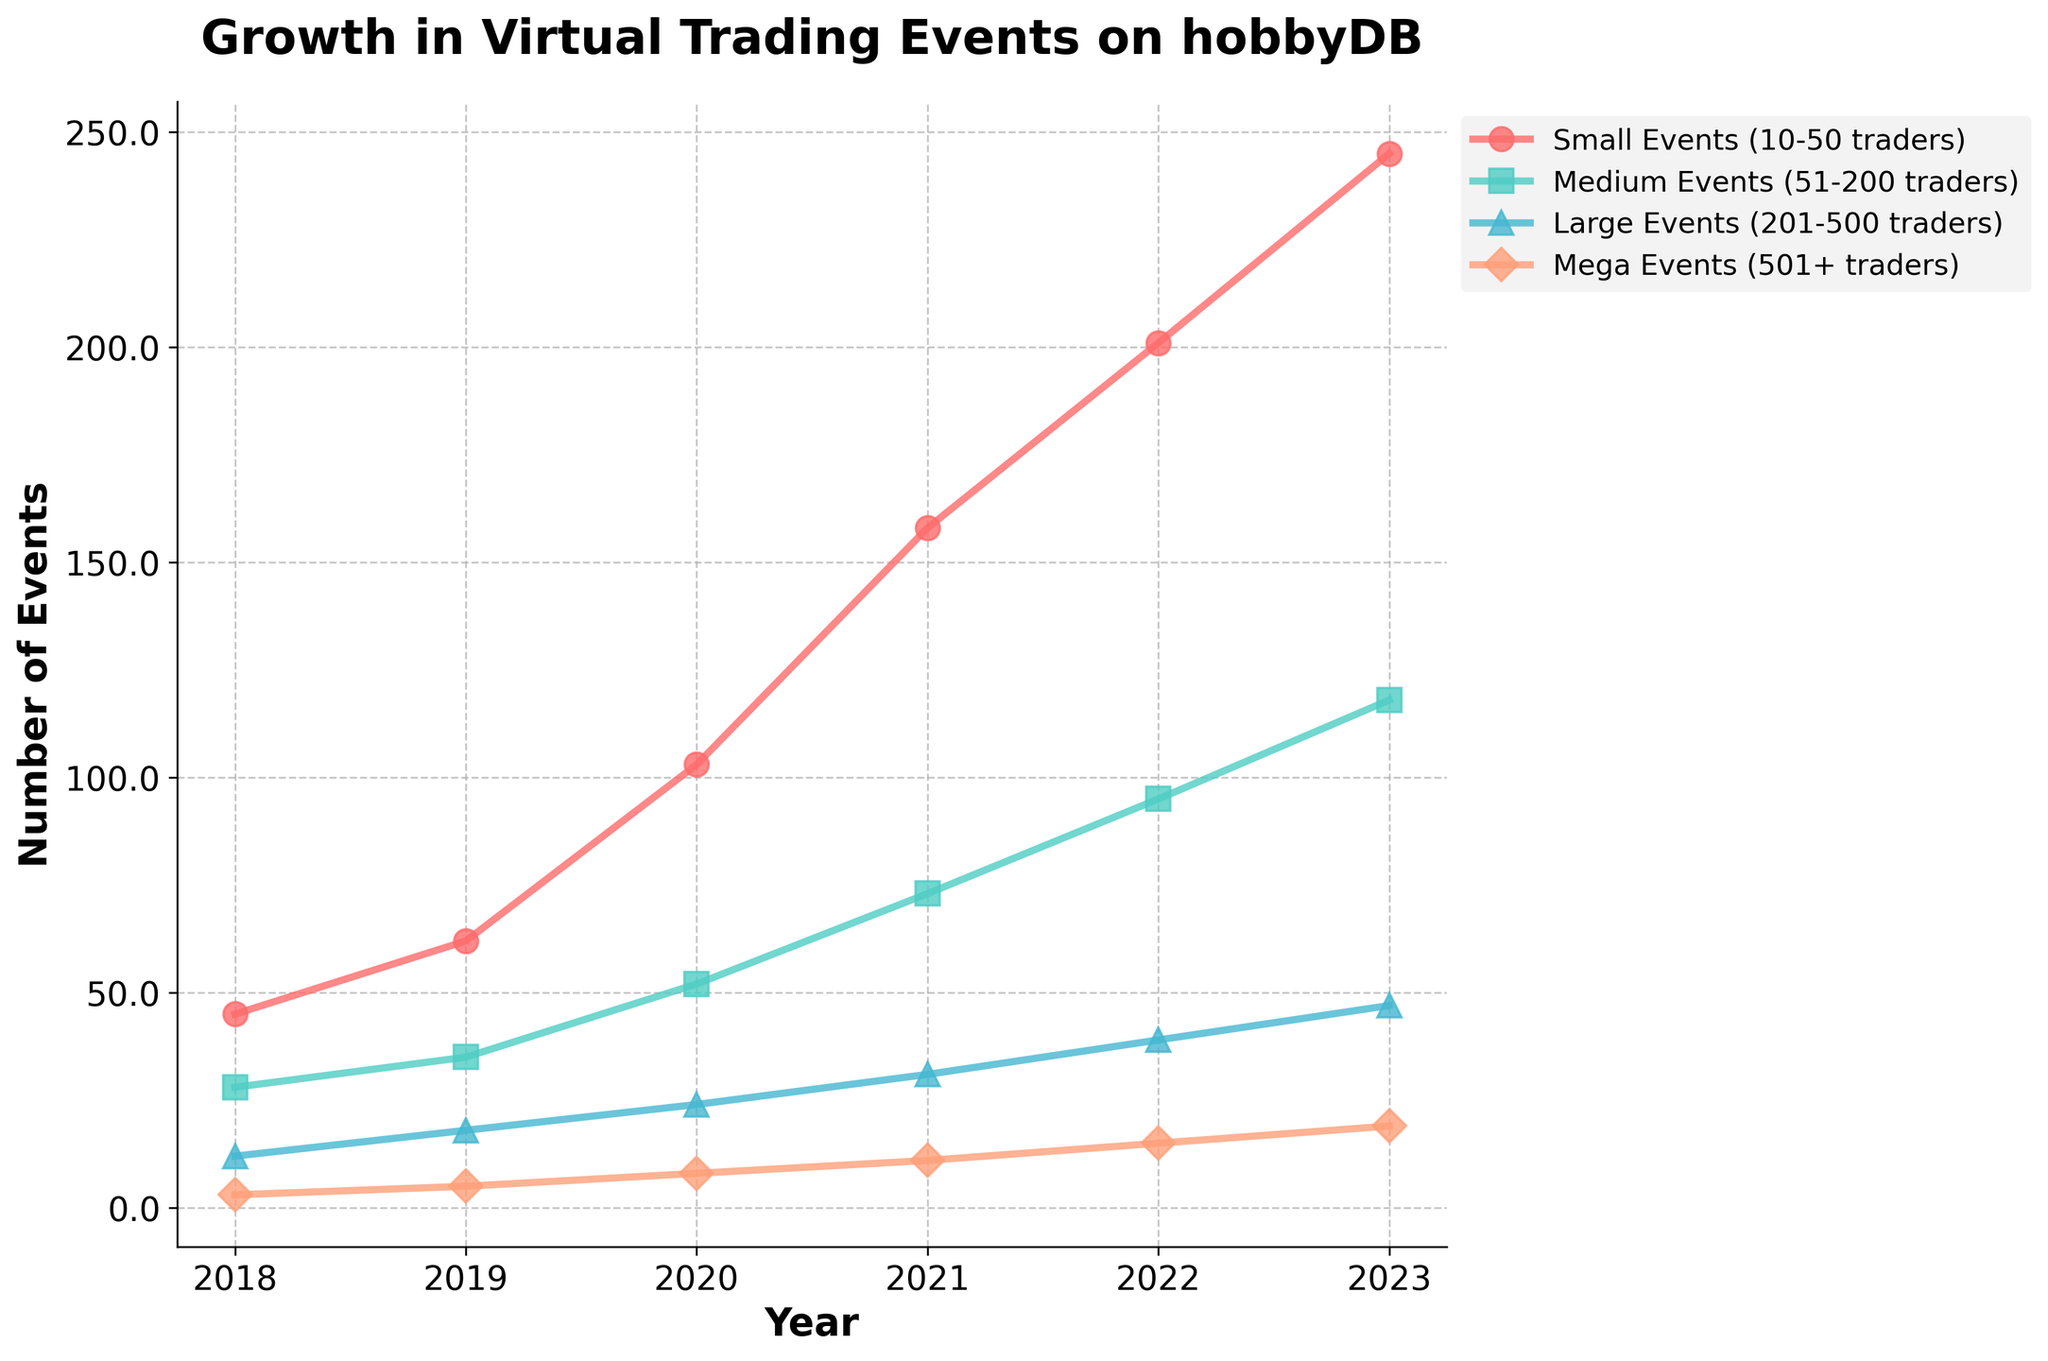Which year had the highest number of Small Events (10-50 traders)? Look for the peak point on the red line representing Small Events in the figure and find the corresponding year on the x-axis.
Answer: 2023 How many Mega Events (501+ traders) were there in 2022? Identify the point on the orange line corresponding to 2022 and read the y-value.
Answer: 15 What is the total number of trading events across all categories in 2021? Add the values for all event sizes in 2021: 158 (Small) + 73 (Medium) + 31 (Large) + 11 (Mega). The sum is 273.
Answer: 273 In which year did Medium Events (51-200 traders) surpass 50 events for the first time? Look at the turquoise line and identify the year where the y-value exceeds 50, which is 2020.
Answer: 2020 How much did the number of Large Events (201-500 traders) increase from 2019 to 2023? Calculate the difference in the number of Large Events between 2023 and 2019: 47 (2023) - 18 (2019). The result is 29.
Answer: 29 Which category of events showed the most growth between 2018 and 2023? Compare the difference in the y-values for each category from 2018 to 2023 and identify the largest increase. Small Events increased from 45 to 245, which is an increase of 200—the largest growth among all categories.
Answer: Small Events Are there more Medium Events or Large Events in 2020? Compare the y-values of the turquoise and purple lines in 2020. Medium Events are 52, while Large Events are 24.
Answer: Medium Events What is the average number of Mega Events (501+ traders) between 2018 and 2023? Sum the values for Mega Events from 2018 to 2023 (3+5+8+11+15+19=61) and divide by the number of years (6). The average is 61/6, which is approximately 10.17.
Answer: 10.17 Which year saw the largest year-over-year increase in Small Events (10-50 traders)? Calculate the year-over-year differences for Small Events and find the largest. 2018 to 2019: 62-45=17, 2019 to 2020: 103-62=41, 2020 to 2021: 158-103=55, 2021 to 2022: 201-158=43, 2022 to 2023: 245-201=44. The largest increase is between 2020 and 2021, with a rise of 55 events.
Answer: 2020 to 2021 